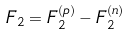Convert formula to latex. <formula><loc_0><loc_0><loc_500><loc_500>F _ { 2 } = F _ { 2 } ^ { ( p ) } - F _ { 2 } ^ { ( n ) }</formula> 